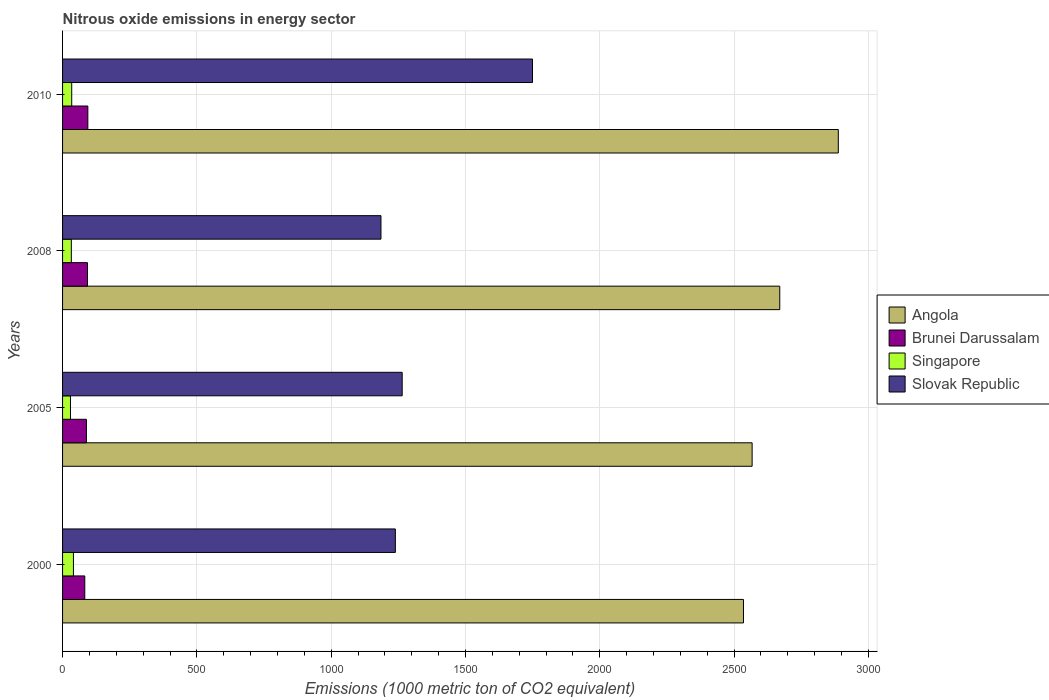How many different coloured bars are there?
Your answer should be compact. 4. Are the number of bars per tick equal to the number of legend labels?
Give a very brief answer. Yes. Are the number of bars on each tick of the Y-axis equal?
Provide a succinct answer. Yes. How many bars are there on the 3rd tick from the bottom?
Your answer should be very brief. 4. What is the label of the 3rd group of bars from the top?
Ensure brevity in your answer.  2005. What is the amount of nitrous oxide emitted in Brunei Darussalam in 2008?
Provide a short and direct response. 92.7. Across all years, what is the maximum amount of nitrous oxide emitted in Slovak Republic?
Give a very brief answer. 1749.7. Across all years, what is the minimum amount of nitrous oxide emitted in Singapore?
Provide a short and direct response. 29.5. What is the total amount of nitrous oxide emitted in Singapore in the graph?
Offer a very short reply. 136.7. What is the difference between the amount of nitrous oxide emitted in Slovak Republic in 2000 and that in 2010?
Provide a short and direct response. -510.6. What is the difference between the amount of nitrous oxide emitted in Singapore in 2010 and the amount of nitrous oxide emitted in Slovak Republic in 2000?
Offer a very short reply. -1205. What is the average amount of nitrous oxide emitted in Singapore per year?
Give a very brief answer. 34.17. In the year 2000, what is the difference between the amount of nitrous oxide emitted in Singapore and amount of nitrous oxide emitted in Brunei Darussalam?
Ensure brevity in your answer.  -42.2. In how many years, is the amount of nitrous oxide emitted in Angola greater than 100 1000 metric ton?
Your response must be concise. 4. What is the ratio of the amount of nitrous oxide emitted in Singapore in 2005 to that in 2010?
Give a very brief answer. 0.87. What is the difference between the highest and the second highest amount of nitrous oxide emitted in Slovak Republic?
Your answer should be compact. 485.2. What is the difference between the highest and the lowest amount of nitrous oxide emitted in Brunei Darussalam?
Your answer should be very brief. 11.4. Is it the case that in every year, the sum of the amount of nitrous oxide emitted in Singapore and amount of nitrous oxide emitted in Slovak Republic is greater than the sum of amount of nitrous oxide emitted in Angola and amount of nitrous oxide emitted in Brunei Darussalam?
Keep it short and to the point. Yes. What does the 2nd bar from the top in 2005 represents?
Provide a succinct answer. Singapore. What does the 3rd bar from the bottom in 2008 represents?
Offer a terse response. Singapore. Is it the case that in every year, the sum of the amount of nitrous oxide emitted in Angola and amount of nitrous oxide emitted in Slovak Republic is greater than the amount of nitrous oxide emitted in Singapore?
Offer a very short reply. Yes. Are all the bars in the graph horizontal?
Offer a very short reply. Yes. How are the legend labels stacked?
Provide a short and direct response. Vertical. What is the title of the graph?
Offer a terse response. Nitrous oxide emissions in energy sector. What is the label or title of the X-axis?
Offer a very short reply. Emissions (1000 metric ton of CO2 equivalent). What is the label or title of the Y-axis?
Your response must be concise. Years. What is the Emissions (1000 metric ton of CO2 equivalent) of Angola in 2000?
Your response must be concise. 2535.2. What is the Emissions (1000 metric ton of CO2 equivalent) of Brunei Darussalam in 2000?
Your answer should be very brief. 82.7. What is the Emissions (1000 metric ton of CO2 equivalent) in Singapore in 2000?
Your answer should be compact. 40.5. What is the Emissions (1000 metric ton of CO2 equivalent) of Slovak Republic in 2000?
Ensure brevity in your answer.  1239.1. What is the Emissions (1000 metric ton of CO2 equivalent) of Angola in 2005?
Provide a short and direct response. 2567.4. What is the Emissions (1000 metric ton of CO2 equivalent) of Brunei Darussalam in 2005?
Offer a terse response. 88.9. What is the Emissions (1000 metric ton of CO2 equivalent) of Singapore in 2005?
Make the answer very short. 29.5. What is the Emissions (1000 metric ton of CO2 equivalent) in Slovak Republic in 2005?
Your answer should be compact. 1264.5. What is the Emissions (1000 metric ton of CO2 equivalent) of Angola in 2008?
Make the answer very short. 2670.3. What is the Emissions (1000 metric ton of CO2 equivalent) of Brunei Darussalam in 2008?
Make the answer very short. 92.7. What is the Emissions (1000 metric ton of CO2 equivalent) of Singapore in 2008?
Provide a succinct answer. 32.6. What is the Emissions (1000 metric ton of CO2 equivalent) in Slovak Republic in 2008?
Provide a succinct answer. 1185.5. What is the Emissions (1000 metric ton of CO2 equivalent) of Angola in 2010?
Make the answer very short. 2888.3. What is the Emissions (1000 metric ton of CO2 equivalent) in Brunei Darussalam in 2010?
Your response must be concise. 94.1. What is the Emissions (1000 metric ton of CO2 equivalent) of Singapore in 2010?
Offer a terse response. 34.1. What is the Emissions (1000 metric ton of CO2 equivalent) of Slovak Republic in 2010?
Make the answer very short. 1749.7. Across all years, what is the maximum Emissions (1000 metric ton of CO2 equivalent) of Angola?
Make the answer very short. 2888.3. Across all years, what is the maximum Emissions (1000 metric ton of CO2 equivalent) in Brunei Darussalam?
Keep it short and to the point. 94.1. Across all years, what is the maximum Emissions (1000 metric ton of CO2 equivalent) in Singapore?
Ensure brevity in your answer.  40.5. Across all years, what is the maximum Emissions (1000 metric ton of CO2 equivalent) in Slovak Republic?
Offer a very short reply. 1749.7. Across all years, what is the minimum Emissions (1000 metric ton of CO2 equivalent) of Angola?
Offer a terse response. 2535.2. Across all years, what is the minimum Emissions (1000 metric ton of CO2 equivalent) in Brunei Darussalam?
Keep it short and to the point. 82.7. Across all years, what is the minimum Emissions (1000 metric ton of CO2 equivalent) of Singapore?
Offer a terse response. 29.5. Across all years, what is the minimum Emissions (1000 metric ton of CO2 equivalent) in Slovak Republic?
Offer a terse response. 1185.5. What is the total Emissions (1000 metric ton of CO2 equivalent) of Angola in the graph?
Your answer should be very brief. 1.07e+04. What is the total Emissions (1000 metric ton of CO2 equivalent) in Brunei Darussalam in the graph?
Give a very brief answer. 358.4. What is the total Emissions (1000 metric ton of CO2 equivalent) in Singapore in the graph?
Provide a short and direct response. 136.7. What is the total Emissions (1000 metric ton of CO2 equivalent) in Slovak Republic in the graph?
Provide a short and direct response. 5438.8. What is the difference between the Emissions (1000 metric ton of CO2 equivalent) in Angola in 2000 and that in 2005?
Provide a short and direct response. -32.2. What is the difference between the Emissions (1000 metric ton of CO2 equivalent) of Brunei Darussalam in 2000 and that in 2005?
Your answer should be compact. -6.2. What is the difference between the Emissions (1000 metric ton of CO2 equivalent) of Singapore in 2000 and that in 2005?
Make the answer very short. 11. What is the difference between the Emissions (1000 metric ton of CO2 equivalent) of Slovak Republic in 2000 and that in 2005?
Provide a succinct answer. -25.4. What is the difference between the Emissions (1000 metric ton of CO2 equivalent) of Angola in 2000 and that in 2008?
Make the answer very short. -135.1. What is the difference between the Emissions (1000 metric ton of CO2 equivalent) of Brunei Darussalam in 2000 and that in 2008?
Ensure brevity in your answer.  -10. What is the difference between the Emissions (1000 metric ton of CO2 equivalent) in Singapore in 2000 and that in 2008?
Offer a terse response. 7.9. What is the difference between the Emissions (1000 metric ton of CO2 equivalent) of Slovak Republic in 2000 and that in 2008?
Provide a succinct answer. 53.6. What is the difference between the Emissions (1000 metric ton of CO2 equivalent) of Angola in 2000 and that in 2010?
Your response must be concise. -353.1. What is the difference between the Emissions (1000 metric ton of CO2 equivalent) in Brunei Darussalam in 2000 and that in 2010?
Ensure brevity in your answer.  -11.4. What is the difference between the Emissions (1000 metric ton of CO2 equivalent) of Singapore in 2000 and that in 2010?
Keep it short and to the point. 6.4. What is the difference between the Emissions (1000 metric ton of CO2 equivalent) of Slovak Republic in 2000 and that in 2010?
Your response must be concise. -510.6. What is the difference between the Emissions (1000 metric ton of CO2 equivalent) of Angola in 2005 and that in 2008?
Provide a succinct answer. -102.9. What is the difference between the Emissions (1000 metric ton of CO2 equivalent) in Brunei Darussalam in 2005 and that in 2008?
Ensure brevity in your answer.  -3.8. What is the difference between the Emissions (1000 metric ton of CO2 equivalent) in Singapore in 2005 and that in 2008?
Ensure brevity in your answer.  -3.1. What is the difference between the Emissions (1000 metric ton of CO2 equivalent) of Slovak Republic in 2005 and that in 2008?
Your answer should be compact. 79. What is the difference between the Emissions (1000 metric ton of CO2 equivalent) in Angola in 2005 and that in 2010?
Your answer should be compact. -320.9. What is the difference between the Emissions (1000 metric ton of CO2 equivalent) in Slovak Republic in 2005 and that in 2010?
Your answer should be very brief. -485.2. What is the difference between the Emissions (1000 metric ton of CO2 equivalent) of Angola in 2008 and that in 2010?
Offer a very short reply. -218. What is the difference between the Emissions (1000 metric ton of CO2 equivalent) of Brunei Darussalam in 2008 and that in 2010?
Give a very brief answer. -1.4. What is the difference between the Emissions (1000 metric ton of CO2 equivalent) of Singapore in 2008 and that in 2010?
Your response must be concise. -1.5. What is the difference between the Emissions (1000 metric ton of CO2 equivalent) of Slovak Republic in 2008 and that in 2010?
Keep it short and to the point. -564.2. What is the difference between the Emissions (1000 metric ton of CO2 equivalent) in Angola in 2000 and the Emissions (1000 metric ton of CO2 equivalent) in Brunei Darussalam in 2005?
Ensure brevity in your answer.  2446.3. What is the difference between the Emissions (1000 metric ton of CO2 equivalent) in Angola in 2000 and the Emissions (1000 metric ton of CO2 equivalent) in Singapore in 2005?
Your answer should be compact. 2505.7. What is the difference between the Emissions (1000 metric ton of CO2 equivalent) of Angola in 2000 and the Emissions (1000 metric ton of CO2 equivalent) of Slovak Republic in 2005?
Make the answer very short. 1270.7. What is the difference between the Emissions (1000 metric ton of CO2 equivalent) in Brunei Darussalam in 2000 and the Emissions (1000 metric ton of CO2 equivalent) in Singapore in 2005?
Provide a short and direct response. 53.2. What is the difference between the Emissions (1000 metric ton of CO2 equivalent) in Brunei Darussalam in 2000 and the Emissions (1000 metric ton of CO2 equivalent) in Slovak Republic in 2005?
Your response must be concise. -1181.8. What is the difference between the Emissions (1000 metric ton of CO2 equivalent) in Singapore in 2000 and the Emissions (1000 metric ton of CO2 equivalent) in Slovak Republic in 2005?
Your answer should be very brief. -1224. What is the difference between the Emissions (1000 metric ton of CO2 equivalent) in Angola in 2000 and the Emissions (1000 metric ton of CO2 equivalent) in Brunei Darussalam in 2008?
Keep it short and to the point. 2442.5. What is the difference between the Emissions (1000 metric ton of CO2 equivalent) of Angola in 2000 and the Emissions (1000 metric ton of CO2 equivalent) of Singapore in 2008?
Give a very brief answer. 2502.6. What is the difference between the Emissions (1000 metric ton of CO2 equivalent) of Angola in 2000 and the Emissions (1000 metric ton of CO2 equivalent) of Slovak Republic in 2008?
Provide a short and direct response. 1349.7. What is the difference between the Emissions (1000 metric ton of CO2 equivalent) of Brunei Darussalam in 2000 and the Emissions (1000 metric ton of CO2 equivalent) of Singapore in 2008?
Your answer should be compact. 50.1. What is the difference between the Emissions (1000 metric ton of CO2 equivalent) in Brunei Darussalam in 2000 and the Emissions (1000 metric ton of CO2 equivalent) in Slovak Republic in 2008?
Offer a very short reply. -1102.8. What is the difference between the Emissions (1000 metric ton of CO2 equivalent) in Singapore in 2000 and the Emissions (1000 metric ton of CO2 equivalent) in Slovak Republic in 2008?
Ensure brevity in your answer.  -1145. What is the difference between the Emissions (1000 metric ton of CO2 equivalent) in Angola in 2000 and the Emissions (1000 metric ton of CO2 equivalent) in Brunei Darussalam in 2010?
Your response must be concise. 2441.1. What is the difference between the Emissions (1000 metric ton of CO2 equivalent) in Angola in 2000 and the Emissions (1000 metric ton of CO2 equivalent) in Singapore in 2010?
Provide a succinct answer. 2501.1. What is the difference between the Emissions (1000 metric ton of CO2 equivalent) in Angola in 2000 and the Emissions (1000 metric ton of CO2 equivalent) in Slovak Republic in 2010?
Offer a very short reply. 785.5. What is the difference between the Emissions (1000 metric ton of CO2 equivalent) in Brunei Darussalam in 2000 and the Emissions (1000 metric ton of CO2 equivalent) in Singapore in 2010?
Provide a succinct answer. 48.6. What is the difference between the Emissions (1000 metric ton of CO2 equivalent) in Brunei Darussalam in 2000 and the Emissions (1000 metric ton of CO2 equivalent) in Slovak Republic in 2010?
Offer a terse response. -1667. What is the difference between the Emissions (1000 metric ton of CO2 equivalent) in Singapore in 2000 and the Emissions (1000 metric ton of CO2 equivalent) in Slovak Republic in 2010?
Provide a short and direct response. -1709.2. What is the difference between the Emissions (1000 metric ton of CO2 equivalent) of Angola in 2005 and the Emissions (1000 metric ton of CO2 equivalent) of Brunei Darussalam in 2008?
Make the answer very short. 2474.7. What is the difference between the Emissions (1000 metric ton of CO2 equivalent) in Angola in 2005 and the Emissions (1000 metric ton of CO2 equivalent) in Singapore in 2008?
Your answer should be compact. 2534.8. What is the difference between the Emissions (1000 metric ton of CO2 equivalent) of Angola in 2005 and the Emissions (1000 metric ton of CO2 equivalent) of Slovak Republic in 2008?
Your answer should be compact. 1381.9. What is the difference between the Emissions (1000 metric ton of CO2 equivalent) of Brunei Darussalam in 2005 and the Emissions (1000 metric ton of CO2 equivalent) of Singapore in 2008?
Keep it short and to the point. 56.3. What is the difference between the Emissions (1000 metric ton of CO2 equivalent) in Brunei Darussalam in 2005 and the Emissions (1000 metric ton of CO2 equivalent) in Slovak Republic in 2008?
Provide a short and direct response. -1096.6. What is the difference between the Emissions (1000 metric ton of CO2 equivalent) in Singapore in 2005 and the Emissions (1000 metric ton of CO2 equivalent) in Slovak Republic in 2008?
Give a very brief answer. -1156. What is the difference between the Emissions (1000 metric ton of CO2 equivalent) of Angola in 2005 and the Emissions (1000 metric ton of CO2 equivalent) of Brunei Darussalam in 2010?
Keep it short and to the point. 2473.3. What is the difference between the Emissions (1000 metric ton of CO2 equivalent) in Angola in 2005 and the Emissions (1000 metric ton of CO2 equivalent) in Singapore in 2010?
Your answer should be very brief. 2533.3. What is the difference between the Emissions (1000 metric ton of CO2 equivalent) in Angola in 2005 and the Emissions (1000 metric ton of CO2 equivalent) in Slovak Republic in 2010?
Ensure brevity in your answer.  817.7. What is the difference between the Emissions (1000 metric ton of CO2 equivalent) of Brunei Darussalam in 2005 and the Emissions (1000 metric ton of CO2 equivalent) of Singapore in 2010?
Your answer should be very brief. 54.8. What is the difference between the Emissions (1000 metric ton of CO2 equivalent) of Brunei Darussalam in 2005 and the Emissions (1000 metric ton of CO2 equivalent) of Slovak Republic in 2010?
Your answer should be very brief. -1660.8. What is the difference between the Emissions (1000 metric ton of CO2 equivalent) in Singapore in 2005 and the Emissions (1000 metric ton of CO2 equivalent) in Slovak Republic in 2010?
Ensure brevity in your answer.  -1720.2. What is the difference between the Emissions (1000 metric ton of CO2 equivalent) of Angola in 2008 and the Emissions (1000 metric ton of CO2 equivalent) of Brunei Darussalam in 2010?
Give a very brief answer. 2576.2. What is the difference between the Emissions (1000 metric ton of CO2 equivalent) in Angola in 2008 and the Emissions (1000 metric ton of CO2 equivalent) in Singapore in 2010?
Keep it short and to the point. 2636.2. What is the difference between the Emissions (1000 metric ton of CO2 equivalent) in Angola in 2008 and the Emissions (1000 metric ton of CO2 equivalent) in Slovak Republic in 2010?
Ensure brevity in your answer.  920.6. What is the difference between the Emissions (1000 metric ton of CO2 equivalent) in Brunei Darussalam in 2008 and the Emissions (1000 metric ton of CO2 equivalent) in Singapore in 2010?
Offer a very short reply. 58.6. What is the difference between the Emissions (1000 metric ton of CO2 equivalent) of Brunei Darussalam in 2008 and the Emissions (1000 metric ton of CO2 equivalent) of Slovak Republic in 2010?
Offer a terse response. -1657. What is the difference between the Emissions (1000 metric ton of CO2 equivalent) of Singapore in 2008 and the Emissions (1000 metric ton of CO2 equivalent) of Slovak Republic in 2010?
Offer a very short reply. -1717.1. What is the average Emissions (1000 metric ton of CO2 equivalent) of Angola per year?
Your response must be concise. 2665.3. What is the average Emissions (1000 metric ton of CO2 equivalent) of Brunei Darussalam per year?
Give a very brief answer. 89.6. What is the average Emissions (1000 metric ton of CO2 equivalent) in Singapore per year?
Your response must be concise. 34.17. What is the average Emissions (1000 metric ton of CO2 equivalent) of Slovak Republic per year?
Make the answer very short. 1359.7. In the year 2000, what is the difference between the Emissions (1000 metric ton of CO2 equivalent) of Angola and Emissions (1000 metric ton of CO2 equivalent) of Brunei Darussalam?
Give a very brief answer. 2452.5. In the year 2000, what is the difference between the Emissions (1000 metric ton of CO2 equivalent) of Angola and Emissions (1000 metric ton of CO2 equivalent) of Singapore?
Offer a very short reply. 2494.7. In the year 2000, what is the difference between the Emissions (1000 metric ton of CO2 equivalent) of Angola and Emissions (1000 metric ton of CO2 equivalent) of Slovak Republic?
Your response must be concise. 1296.1. In the year 2000, what is the difference between the Emissions (1000 metric ton of CO2 equivalent) in Brunei Darussalam and Emissions (1000 metric ton of CO2 equivalent) in Singapore?
Offer a terse response. 42.2. In the year 2000, what is the difference between the Emissions (1000 metric ton of CO2 equivalent) in Brunei Darussalam and Emissions (1000 metric ton of CO2 equivalent) in Slovak Republic?
Offer a terse response. -1156.4. In the year 2000, what is the difference between the Emissions (1000 metric ton of CO2 equivalent) of Singapore and Emissions (1000 metric ton of CO2 equivalent) of Slovak Republic?
Provide a short and direct response. -1198.6. In the year 2005, what is the difference between the Emissions (1000 metric ton of CO2 equivalent) in Angola and Emissions (1000 metric ton of CO2 equivalent) in Brunei Darussalam?
Keep it short and to the point. 2478.5. In the year 2005, what is the difference between the Emissions (1000 metric ton of CO2 equivalent) in Angola and Emissions (1000 metric ton of CO2 equivalent) in Singapore?
Ensure brevity in your answer.  2537.9. In the year 2005, what is the difference between the Emissions (1000 metric ton of CO2 equivalent) in Angola and Emissions (1000 metric ton of CO2 equivalent) in Slovak Republic?
Your answer should be very brief. 1302.9. In the year 2005, what is the difference between the Emissions (1000 metric ton of CO2 equivalent) in Brunei Darussalam and Emissions (1000 metric ton of CO2 equivalent) in Singapore?
Provide a short and direct response. 59.4. In the year 2005, what is the difference between the Emissions (1000 metric ton of CO2 equivalent) of Brunei Darussalam and Emissions (1000 metric ton of CO2 equivalent) of Slovak Republic?
Provide a short and direct response. -1175.6. In the year 2005, what is the difference between the Emissions (1000 metric ton of CO2 equivalent) in Singapore and Emissions (1000 metric ton of CO2 equivalent) in Slovak Republic?
Keep it short and to the point. -1235. In the year 2008, what is the difference between the Emissions (1000 metric ton of CO2 equivalent) in Angola and Emissions (1000 metric ton of CO2 equivalent) in Brunei Darussalam?
Your answer should be very brief. 2577.6. In the year 2008, what is the difference between the Emissions (1000 metric ton of CO2 equivalent) in Angola and Emissions (1000 metric ton of CO2 equivalent) in Singapore?
Offer a terse response. 2637.7. In the year 2008, what is the difference between the Emissions (1000 metric ton of CO2 equivalent) of Angola and Emissions (1000 metric ton of CO2 equivalent) of Slovak Republic?
Keep it short and to the point. 1484.8. In the year 2008, what is the difference between the Emissions (1000 metric ton of CO2 equivalent) of Brunei Darussalam and Emissions (1000 metric ton of CO2 equivalent) of Singapore?
Provide a succinct answer. 60.1. In the year 2008, what is the difference between the Emissions (1000 metric ton of CO2 equivalent) in Brunei Darussalam and Emissions (1000 metric ton of CO2 equivalent) in Slovak Republic?
Make the answer very short. -1092.8. In the year 2008, what is the difference between the Emissions (1000 metric ton of CO2 equivalent) in Singapore and Emissions (1000 metric ton of CO2 equivalent) in Slovak Republic?
Offer a terse response. -1152.9. In the year 2010, what is the difference between the Emissions (1000 metric ton of CO2 equivalent) of Angola and Emissions (1000 metric ton of CO2 equivalent) of Brunei Darussalam?
Ensure brevity in your answer.  2794.2. In the year 2010, what is the difference between the Emissions (1000 metric ton of CO2 equivalent) of Angola and Emissions (1000 metric ton of CO2 equivalent) of Singapore?
Your answer should be very brief. 2854.2. In the year 2010, what is the difference between the Emissions (1000 metric ton of CO2 equivalent) of Angola and Emissions (1000 metric ton of CO2 equivalent) of Slovak Republic?
Offer a terse response. 1138.6. In the year 2010, what is the difference between the Emissions (1000 metric ton of CO2 equivalent) of Brunei Darussalam and Emissions (1000 metric ton of CO2 equivalent) of Singapore?
Your answer should be compact. 60. In the year 2010, what is the difference between the Emissions (1000 metric ton of CO2 equivalent) in Brunei Darussalam and Emissions (1000 metric ton of CO2 equivalent) in Slovak Republic?
Make the answer very short. -1655.6. In the year 2010, what is the difference between the Emissions (1000 metric ton of CO2 equivalent) in Singapore and Emissions (1000 metric ton of CO2 equivalent) in Slovak Republic?
Ensure brevity in your answer.  -1715.6. What is the ratio of the Emissions (1000 metric ton of CO2 equivalent) in Angola in 2000 to that in 2005?
Make the answer very short. 0.99. What is the ratio of the Emissions (1000 metric ton of CO2 equivalent) in Brunei Darussalam in 2000 to that in 2005?
Your response must be concise. 0.93. What is the ratio of the Emissions (1000 metric ton of CO2 equivalent) of Singapore in 2000 to that in 2005?
Give a very brief answer. 1.37. What is the ratio of the Emissions (1000 metric ton of CO2 equivalent) in Slovak Republic in 2000 to that in 2005?
Make the answer very short. 0.98. What is the ratio of the Emissions (1000 metric ton of CO2 equivalent) in Angola in 2000 to that in 2008?
Provide a short and direct response. 0.95. What is the ratio of the Emissions (1000 metric ton of CO2 equivalent) of Brunei Darussalam in 2000 to that in 2008?
Provide a short and direct response. 0.89. What is the ratio of the Emissions (1000 metric ton of CO2 equivalent) in Singapore in 2000 to that in 2008?
Offer a very short reply. 1.24. What is the ratio of the Emissions (1000 metric ton of CO2 equivalent) in Slovak Republic in 2000 to that in 2008?
Your response must be concise. 1.05. What is the ratio of the Emissions (1000 metric ton of CO2 equivalent) in Angola in 2000 to that in 2010?
Provide a short and direct response. 0.88. What is the ratio of the Emissions (1000 metric ton of CO2 equivalent) in Brunei Darussalam in 2000 to that in 2010?
Your answer should be very brief. 0.88. What is the ratio of the Emissions (1000 metric ton of CO2 equivalent) of Singapore in 2000 to that in 2010?
Keep it short and to the point. 1.19. What is the ratio of the Emissions (1000 metric ton of CO2 equivalent) in Slovak Republic in 2000 to that in 2010?
Your answer should be very brief. 0.71. What is the ratio of the Emissions (1000 metric ton of CO2 equivalent) in Angola in 2005 to that in 2008?
Offer a terse response. 0.96. What is the ratio of the Emissions (1000 metric ton of CO2 equivalent) in Brunei Darussalam in 2005 to that in 2008?
Ensure brevity in your answer.  0.96. What is the ratio of the Emissions (1000 metric ton of CO2 equivalent) of Singapore in 2005 to that in 2008?
Offer a terse response. 0.9. What is the ratio of the Emissions (1000 metric ton of CO2 equivalent) in Slovak Republic in 2005 to that in 2008?
Your response must be concise. 1.07. What is the ratio of the Emissions (1000 metric ton of CO2 equivalent) in Brunei Darussalam in 2005 to that in 2010?
Ensure brevity in your answer.  0.94. What is the ratio of the Emissions (1000 metric ton of CO2 equivalent) in Singapore in 2005 to that in 2010?
Provide a short and direct response. 0.87. What is the ratio of the Emissions (1000 metric ton of CO2 equivalent) in Slovak Republic in 2005 to that in 2010?
Offer a very short reply. 0.72. What is the ratio of the Emissions (1000 metric ton of CO2 equivalent) in Angola in 2008 to that in 2010?
Your response must be concise. 0.92. What is the ratio of the Emissions (1000 metric ton of CO2 equivalent) in Brunei Darussalam in 2008 to that in 2010?
Offer a terse response. 0.99. What is the ratio of the Emissions (1000 metric ton of CO2 equivalent) in Singapore in 2008 to that in 2010?
Make the answer very short. 0.96. What is the ratio of the Emissions (1000 metric ton of CO2 equivalent) in Slovak Republic in 2008 to that in 2010?
Provide a succinct answer. 0.68. What is the difference between the highest and the second highest Emissions (1000 metric ton of CO2 equivalent) in Angola?
Offer a terse response. 218. What is the difference between the highest and the second highest Emissions (1000 metric ton of CO2 equivalent) in Slovak Republic?
Make the answer very short. 485.2. What is the difference between the highest and the lowest Emissions (1000 metric ton of CO2 equivalent) of Angola?
Offer a very short reply. 353.1. What is the difference between the highest and the lowest Emissions (1000 metric ton of CO2 equivalent) of Brunei Darussalam?
Your response must be concise. 11.4. What is the difference between the highest and the lowest Emissions (1000 metric ton of CO2 equivalent) of Singapore?
Give a very brief answer. 11. What is the difference between the highest and the lowest Emissions (1000 metric ton of CO2 equivalent) in Slovak Republic?
Your response must be concise. 564.2. 